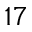<formula> <loc_0><loc_0><loc_500><loc_500>^ { 1 7 }</formula> 